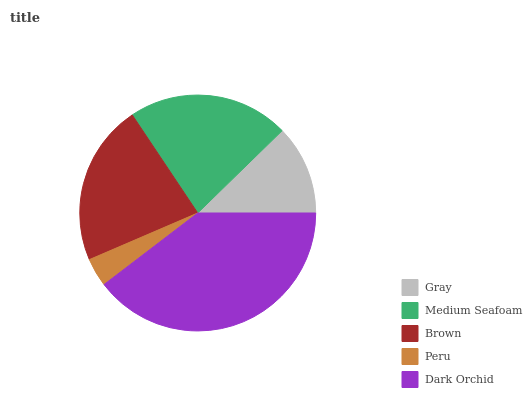Is Peru the minimum?
Answer yes or no. Yes. Is Dark Orchid the maximum?
Answer yes or no. Yes. Is Medium Seafoam the minimum?
Answer yes or no. No. Is Medium Seafoam the maximum?
Answer yes or no. No. Is Medium Seafoam greater than Gray?
Answer yes or no. Yes. Is Gray less than Medium Seafoam?
Answer yes or no. Yes. Is Gray greater than Medium Seafoam?
Answer yes or no. No. Is Medium Seafoam less than Gray?
Answer yes or no. No. Is Medium Seafoam the high median?
Answer yes or no. Yes. Is Medium Seafoam the low median?
Answer yes or no. Yes. Is Peru the high median?
Answer yes or no. No. Is Gray the low median?
Answer yes or no. No. 